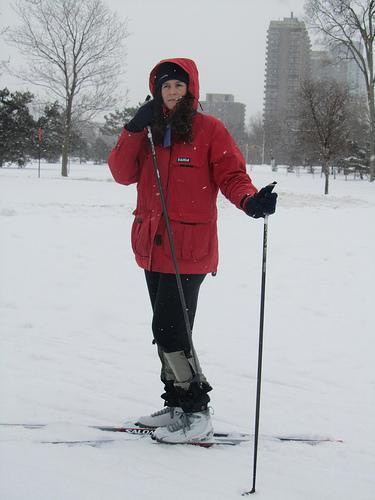How many people are in the picture?
Give a very brief answer. 1. 